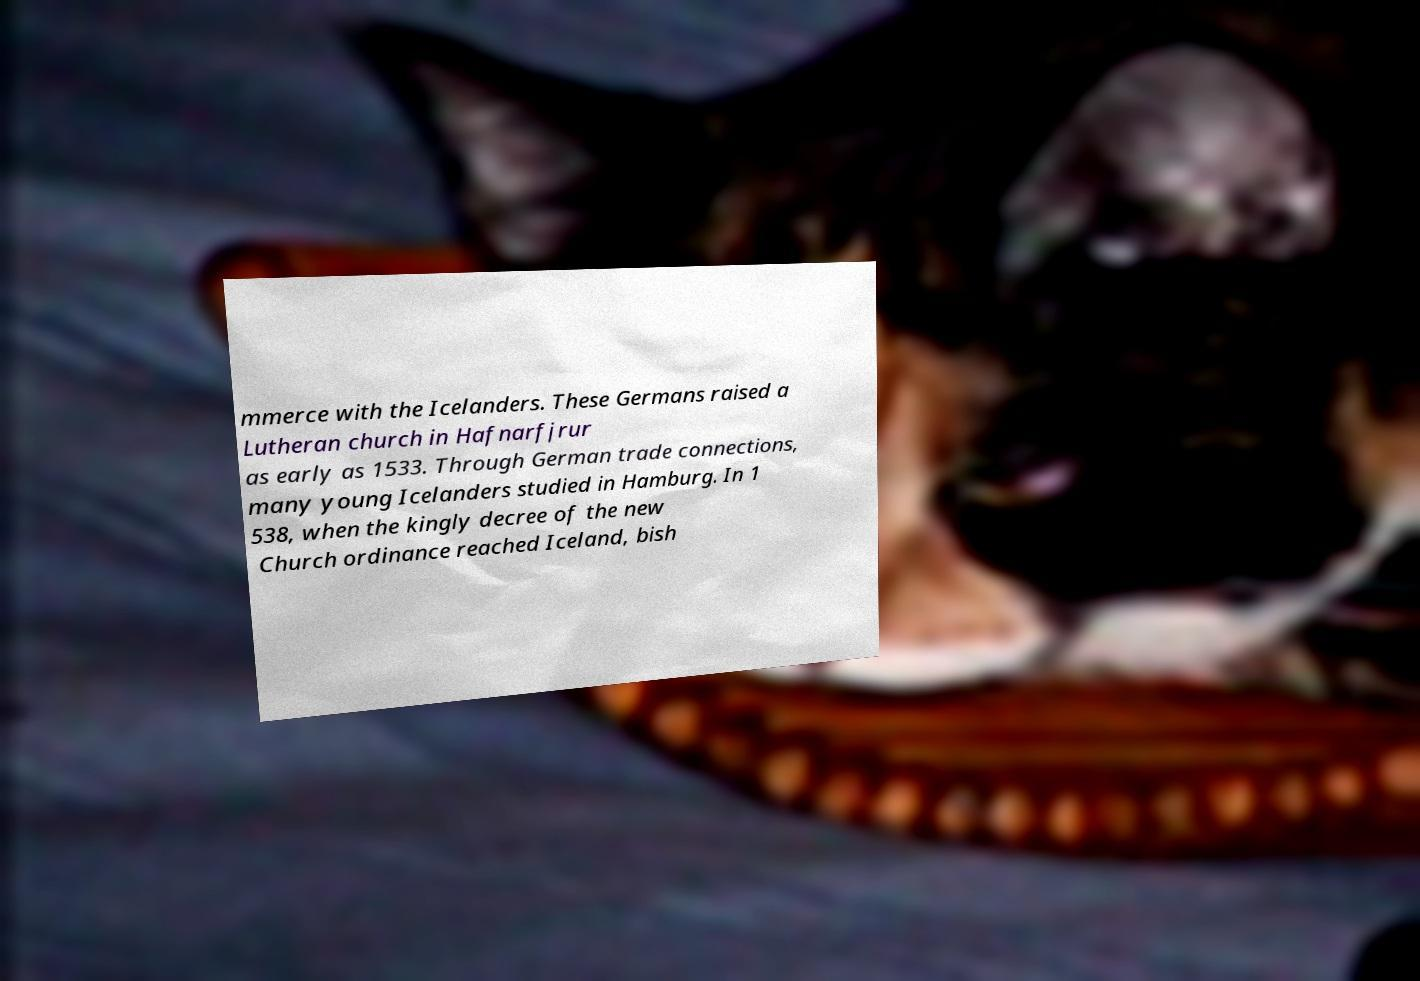Could you assist in decoding the text presented in this image and type it out clearly? mmerce with the Icelanders. These Germans raised a Lutheran church in Hafnarfjrur as early as 1533. Through German trade connections, many young Icelanders studied in Hamburg. In 1 538, when the kingly decree of the new Church ordinance reached Iceland, bish 